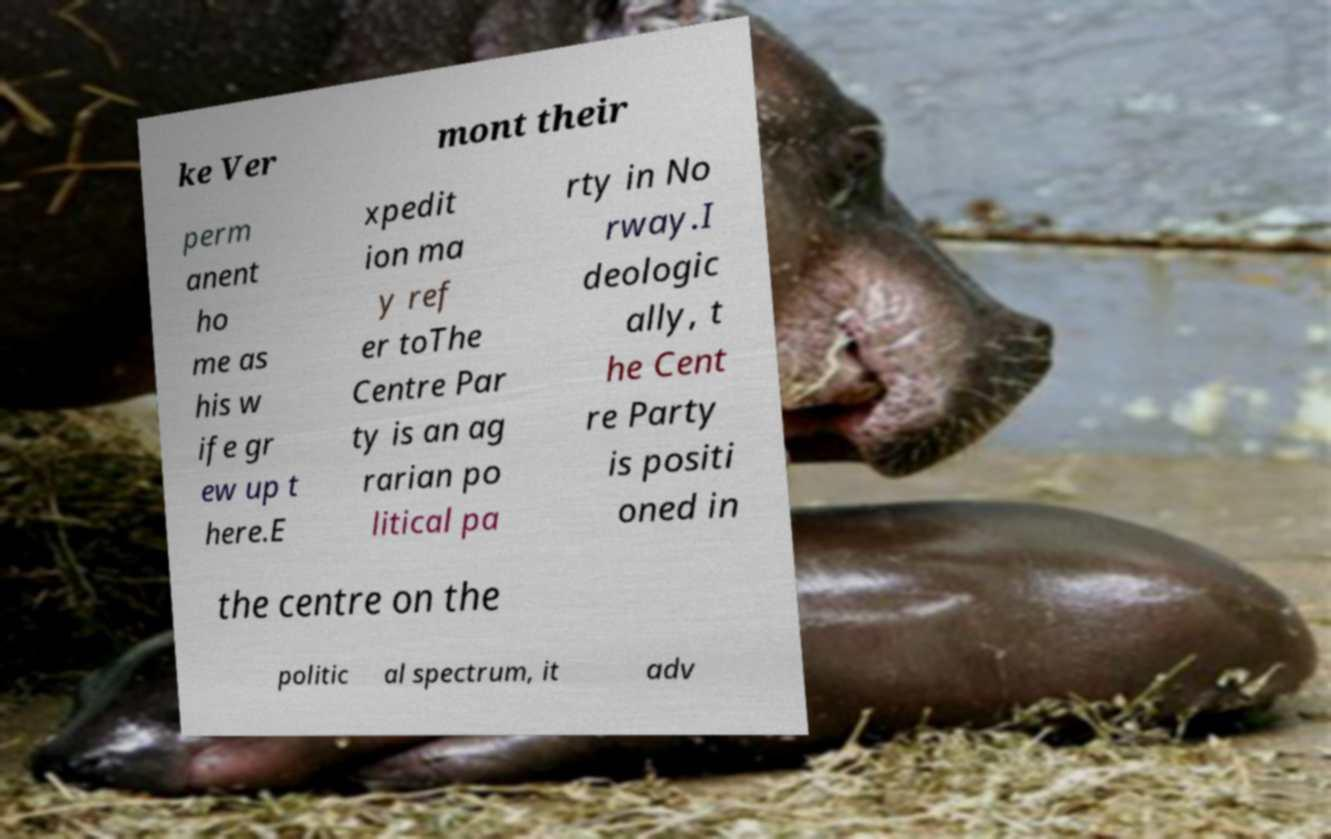I need the written content from this picture converted into text. Can you do that? ke Ver mont their perm anent ho me as his w ife gr ew up t here.E xpedit ion ma y ref er toThe Centre Par ty is an ag rarian po litical pa rty in No rway.I deologic ally, t he Cent re Party is positi oned in the centre on the politic al spectrum, it adv 